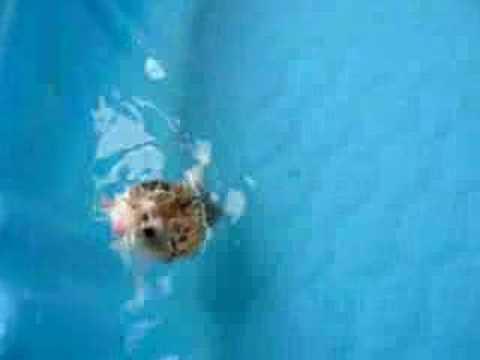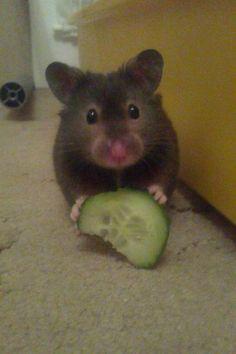The first image is the image on the left, the second image is the image on the right. Evaluate the accuracy of this statement regarding the images: "Each image shows at least one hamster on a green surface, and at least one image shows a hamster in a round green plastic object.". Is it true? Answer yes or no. No. The first image is the image on the left, the second image is the image on the right. Analyze the images presented: Is the assertion "At least one hamster is swimming in the water." valid? Answer yes or no. Yes. 